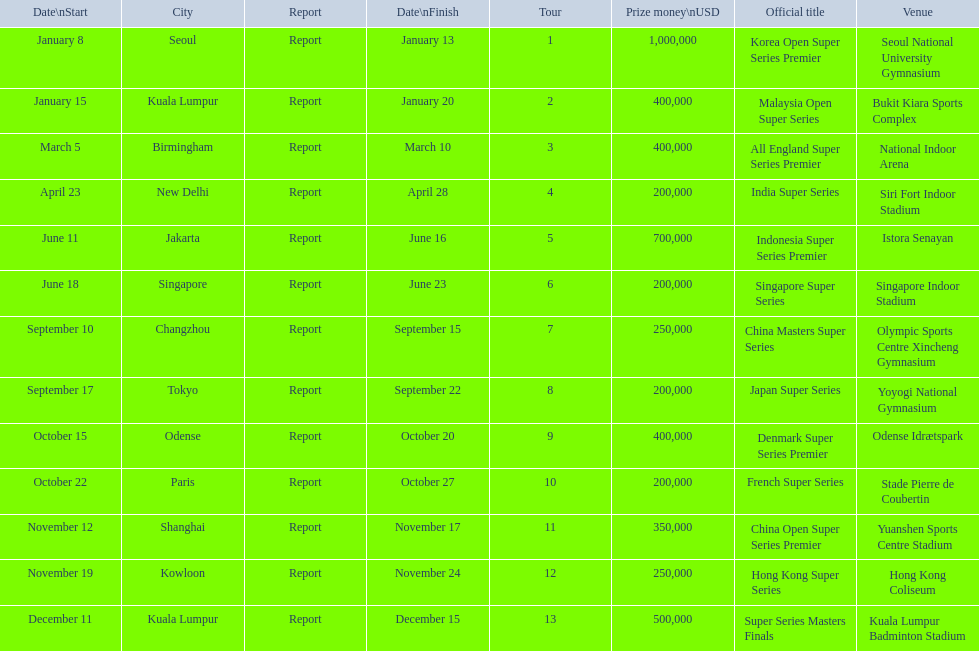What are all the titles? Korea Open Super Series Premier, Malaysia Open Super Series, All England Super Series Premier, India Super Series, Indonesia Super Series Premier, Singapore Super Series, China Masters Super Series, Japan Super Series, Denmark Super Series Premier, French Super Series, China Open Super Series Premier, Hong Kong Super Series, Super Series Masters Finals. When did they take place? January 8, January 15, March 5, April 23, June 11, June 18, September 10, September 17, October 15, October 22, November 12, November 19, December 11. Which title took place in december? Super Series Masters Finals. 